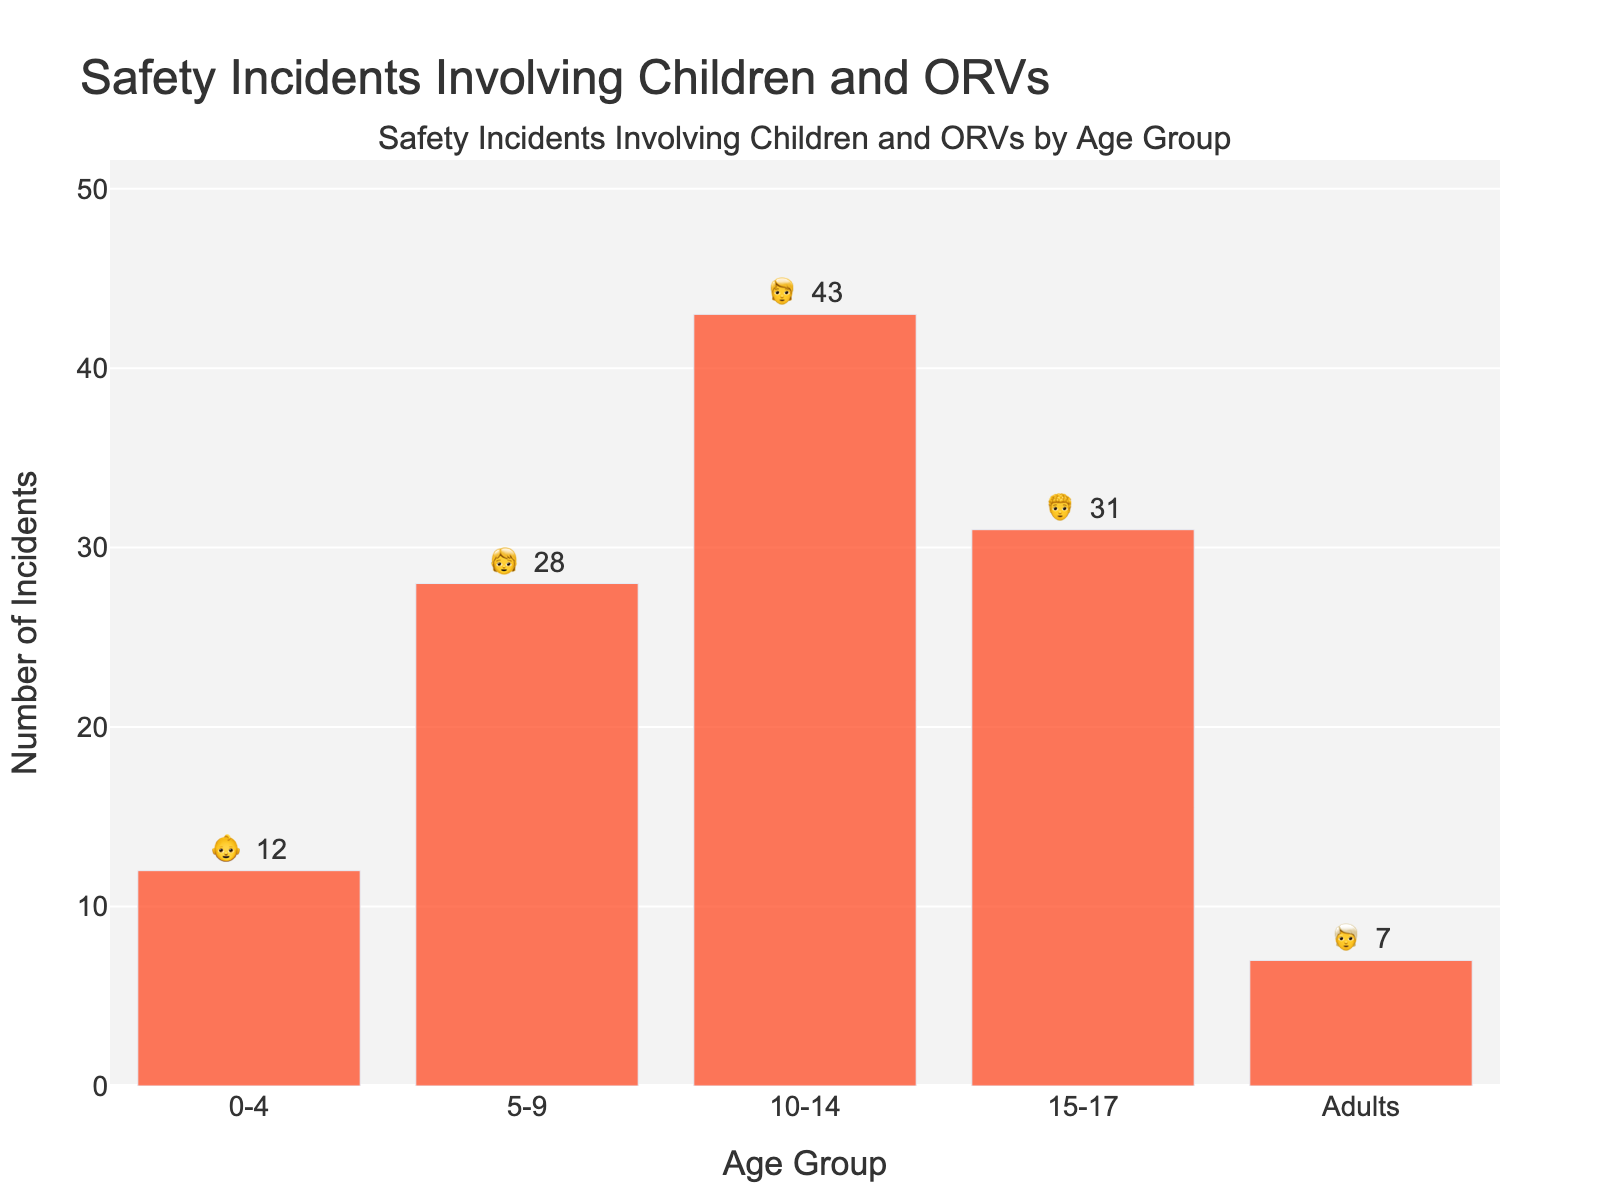Which age group has the highest number of incidents? Looking at the figure, the height of each bar represents the number of incidents. The bar for the age group 10-14 is the highest, indicating that this group has the most incidents.
Answer: 10-14 What's the total number of incidents across all age groups? Add the number of incidents for each age group: 12 (0-4) + 28 (5-9) + 43 (10-14) + 31 (15-17) + 7 (Adults) = 121.
Answer: 121 How many more incidents are there in the 10-14 age group compared to the Adults group? The number of incidents in the 10-14 age group is 43 and in the Adults group is 7. The difference is 43 - 7 = 36.
Answer: 36 Which age group has the least number of incidents? The bar representing Adults has the shortest height, indicating the least number of incidents among the displayed age groups.
Answer: Adults What is the average number of incidents for the age groups 0-4, 5-9, and 10-14? Sum the incidents for the age groups 0-4 (12), 5-9 (28), and 10-14 (43), then divide by the number of groups: (12 + 28 + 43) / 3 ≈ 27.67.
Answer: 27.67 What is the range of the number of incidents among the different age groups? The range is the difference between the highest and lowest values. The highest is 43 (10-14), and the lowest is 7 (Adults). The range is 43 - 7 = 36.
Answer: 36 Which age groups have more incidents than the median value of incidents across all age groups? To find the median, list the number of incidents in ascending order: 7, 12, 28, 31, 43. The median is the middle value, which is 28. The age groups with more than 28 incidents are 10-14 (43) and 15-17 (31).
Answer: 10-14 and 15-17 If we were to group the age ranges into two groups (children and adults), what would be the total incidents in the children's group? Group the incidents for children's age groups (0-4, 5-9, 10-14, 15-17): 12 + 28 + 43 + 31 = 114.
Answer: 114 What is the symbol used for the 0-4 age group on the chart? The emoji displayed next to the 0-4 age group on the bar is 👶.
Answer: 👶 Across which two age groups is the difference in the number of incidents the largest? The largest difference is between the age groups 10-14 (43) and Adults (7). The difference is 43 - 7 = 36.
Answer: 10-14 and Adults 